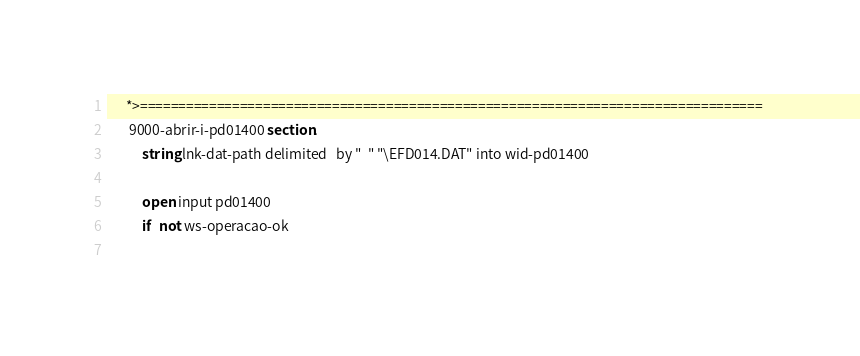<code> <loc_0><loc_0><loc_500><loc_500><_COBOL_>      *>================================================================================= 
       9000-abrir-i-pd01400 section.
           string lnk-dat-path delimited   by "  " "\EFD014.DAT" into wid-pd01400                             
                                           
           open input pd01400
           if   not ws-operacao-ok
                </code> 